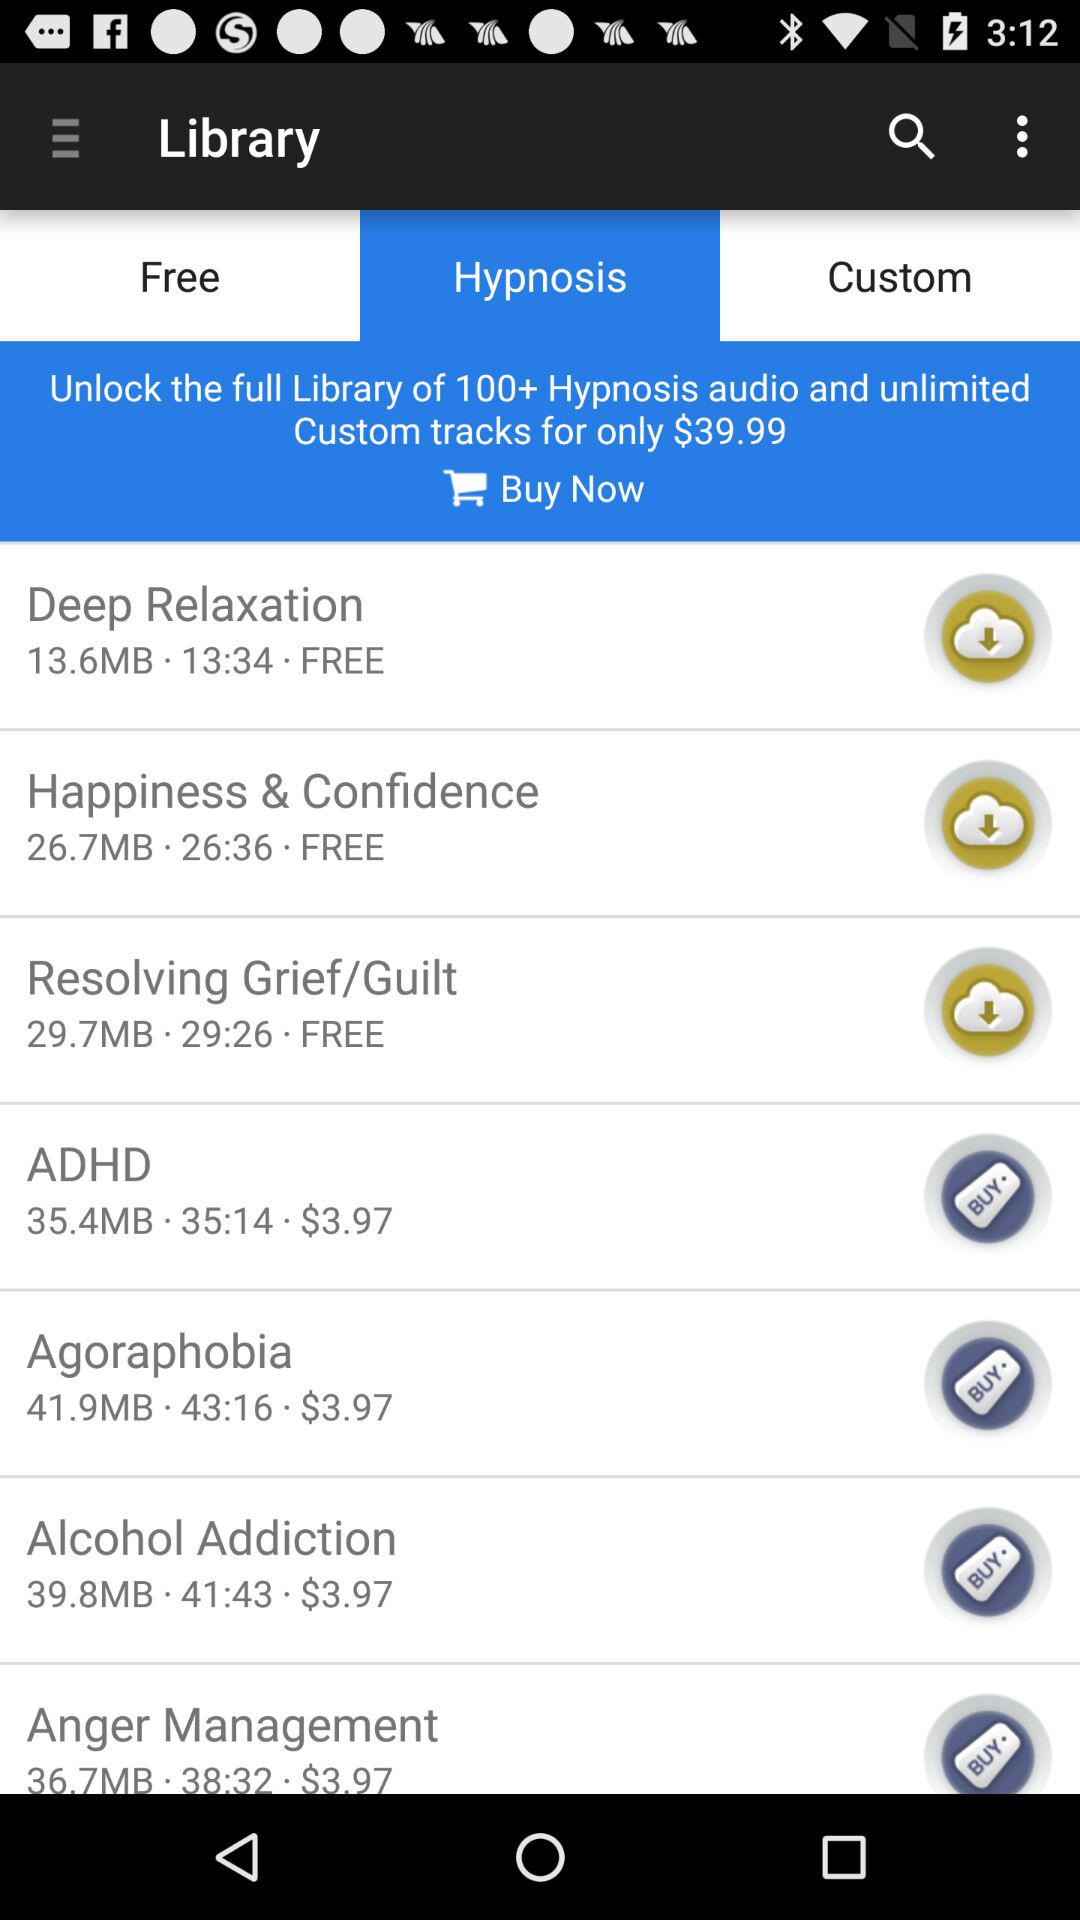What is the price of "Agoraphobia"? The price is $3.97. 